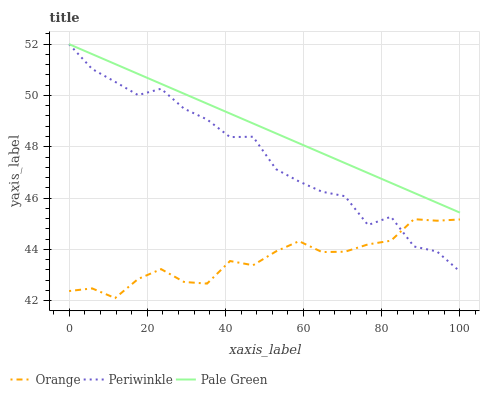Does Orange have the minimum area under the curve?
Answer yes or no. Yes. Does Pale Green have the maximum area under the curve?
Answer yes or no. Yes. Does Periwinkle have the minimum area under the curve?
Answer yes or no. No. Does Periwinkle have the maximum area under the curve?
Answer yes or no. No. Is Pale Green the smoothest?
Answer yes or no. Yes. Is Periwinkle the roughest?
Answer yes or no. Yes. Is Periwinkle the smoothest?
Answer yes or no. No. Is Pale Green the roughest?
Answer yes or no. No. Does Orange have the lowest value?
Answer yes or no. Yes. Does Periwinkle have the lowest value?
Answer yes or no. No. Does Periwinkle have the highest value?
Answer yes or no. Yes. Is Orange less than Pale Green?
Answer yes or no. Yes. Is Pale Green greater than Orange?
Answer yes or no. Yes. Does Pale Green intersect Periwinkle?
Answer yes or no. Yes. Is Pale Green less than Periwinkle?
Answer yes or no. No. Is Pale Green greater than Periwinkle?
Answer yes or no. No. Does Orange intersect Pale Green?
Answer yes or no. No. 